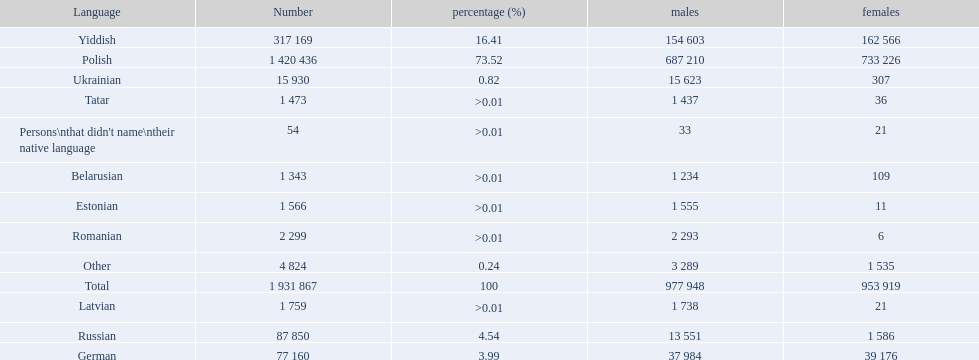What languages are spoken in the warsaw governorate? Polish, Yiddish, Russian, German, Ukrainian, Romanian, Latvian, Estonian, Tatar, Belarusian, Other, Persons\nthat didn't name\ntheir native language. What is the number for russian? 87 850. On this list what is the next lowest number? 77 160. Which language has a number of 77160 speakers? German. 